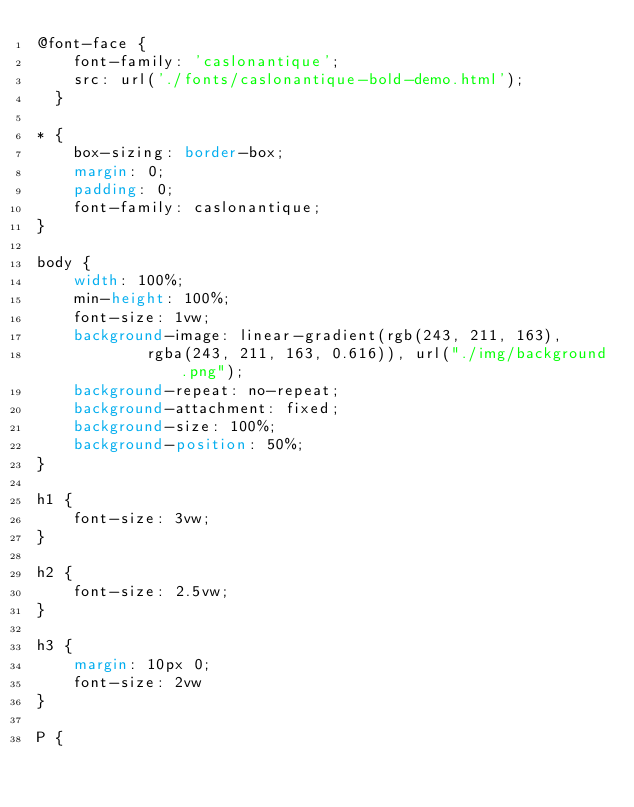<code> <loc_0><loc_0><loc_500><loc_500><_CSS_>@font-face {
    font-family: 'caslonantique';
    src: url('./fonts/caslonantique-bold-demo.html');
  }

* {
    box-sizing: border-box;
    margin: 0;
    padding: 0;
    font-family: caslonantique;
}

body {
    width: 100%;
    min-height: 100%;
    font-size: 1vw;
    background-image: linear-gradient(rgb(243, 211, 163),
            rgba(243, 211, 163, 0.616)), url("./img/background.png");
    background-repeat: no-repeat;
    background-attachment: fixed;
    background-size: 100%;
    background-position: 50%;
}

h1 {
    font-size: 3vw;
}

h2 {
    font-size: 2.5vw;
}

h3 {
    margin: 10px 0;
    font-size: 2vw
}

P {</code> 